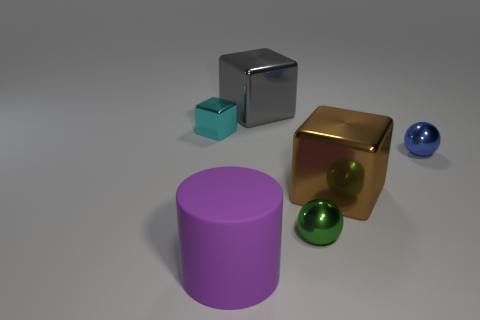Add 3 purple metallic cubes. How many objects exist? 9 Subtract all cylinders. How many objects are left? 5 Subtract all tiny spheres. Subtract all big purple matte objects. How many objects are left? 3 Add 6 blocks. How many blocks are left? 9 Add 3 tiny cyan objects. How many tiny cyan objects exist? 4 Subtract 0 cyan spheres. How many objects are left? 6 